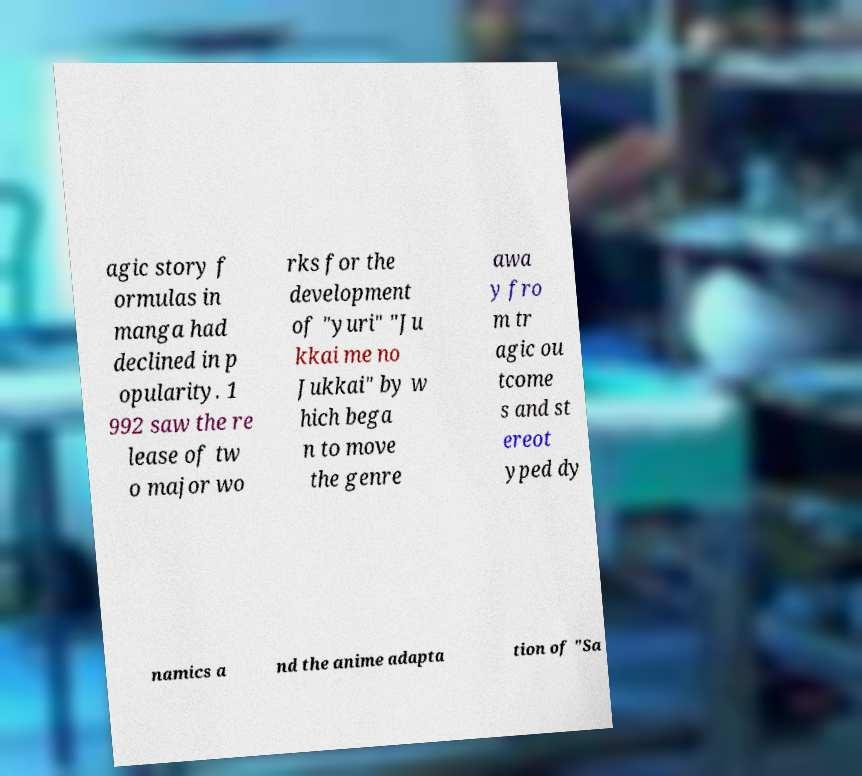Please read and relay the text visible in this image. What does it say? agic story f ormulas in manga had declined in p opularity. 1 992 saw the re lease of tw o major wo rks for the development of "yuri" "Ju kkai me no Jukkai" by w hich bega n to move the genre awa y fro m tr agic ou tcome s and st ereot yped dy namics a nd the anime adapta tion of "Sa 